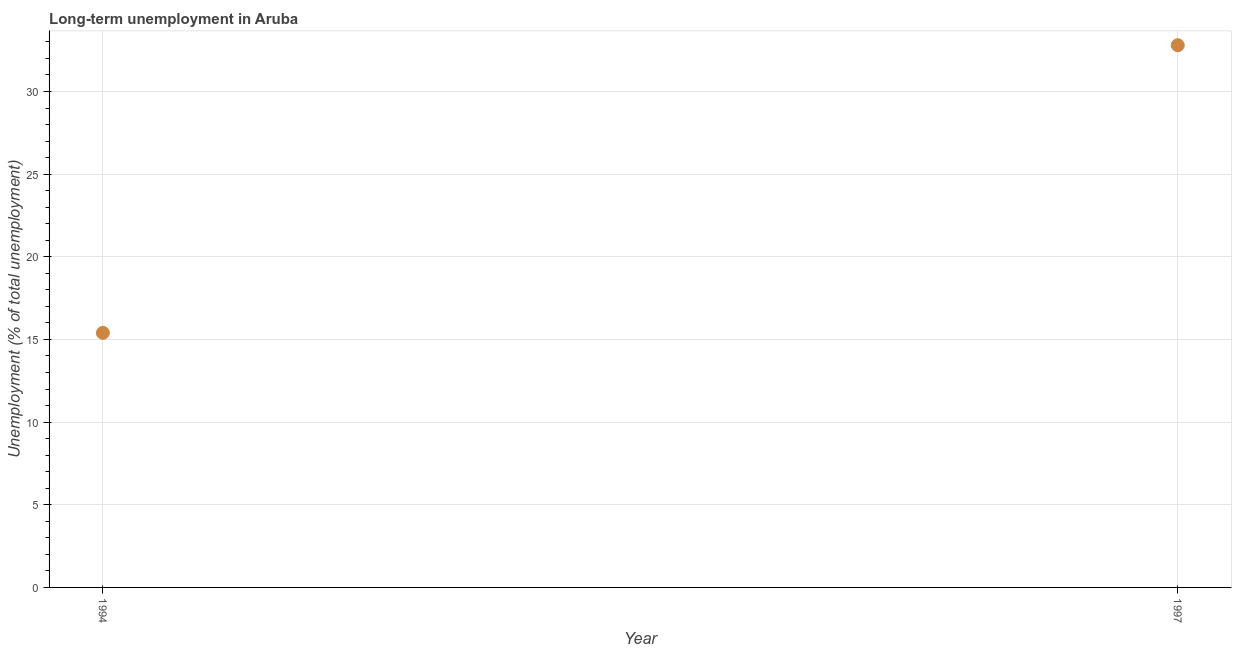What is the long-term unemployment in 1994?
Your response must be concise. 15.4. Across all years, what is the maximum long-term unemployment?
Provide a short and direct response. 32.8. Across all years, what is the minimum long-term unemployment?
Your answer should be very brief. 15.4. In which year was the long-term unemployment maximum?
Make the answer very short. 1997. What is the sum of the long-term unemployment?
Offer a terse response. 48.2. What is the difference between the long-term unemployment in 1994 and 1997?
Provide a short and direct response. -17.4. What is the average long-term unemployment per year?
Your answer should be compact. 24.1. What is the median long-term unemployment?
Ensure brevity in your answer.  24.1. What is the ratio of the long-term unemployment in 1994 to that in 1997?
Provide a short and direct response. 0.47. Is the long-term unemployment in 1994 less than that in 1997?
Your response must be concise. Yes. In how many years, is the long-term unemployment greater than the average long-term unemployment taken over all years?
Provide a short and direct response. 1. How many dotlines are there?
Give a very brief answer. 1. How many years are there in the graph?
Offer a very short reply. 2. Are the values on the major ticks of Y-axis written in scientific E-notation?
Keep it short and to the point. No. What is the title of the graph?
Your answer should be very brief. Long-term unemployment in Aruba. What is the label or title of the X-axis?
Keep it short and to the point. Year. What is the label or title of the Y-axis?
Your response must be concise. Unemployment (% of total unemployment). What is the Unemployment (% of total unemployment) in 1994?
Provide a short and direct response. 15.4. What is the Unemployment (% of total unemployment) in 1997?
Give a very brief answer. 32.8. What is the difference between the Unemployment (% of total unemployment) in 1994 and 1997?
Your response must be concise. -17.4. What is the ratio of the Unemployment (% of total unemployment) in 1994 to that in 1997?
Your answer should be very brief. 0.47. 